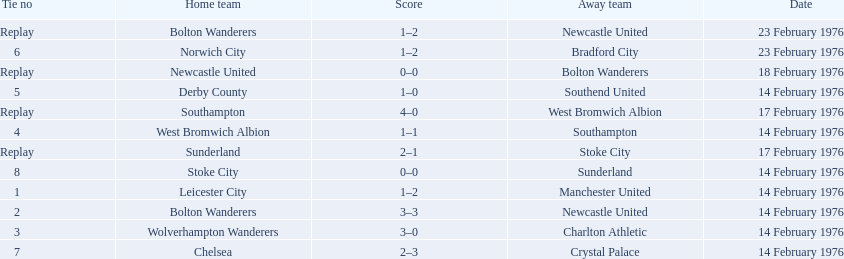What is the game at the top of the table? 1. Who is the home team for this game? Leicester City. 